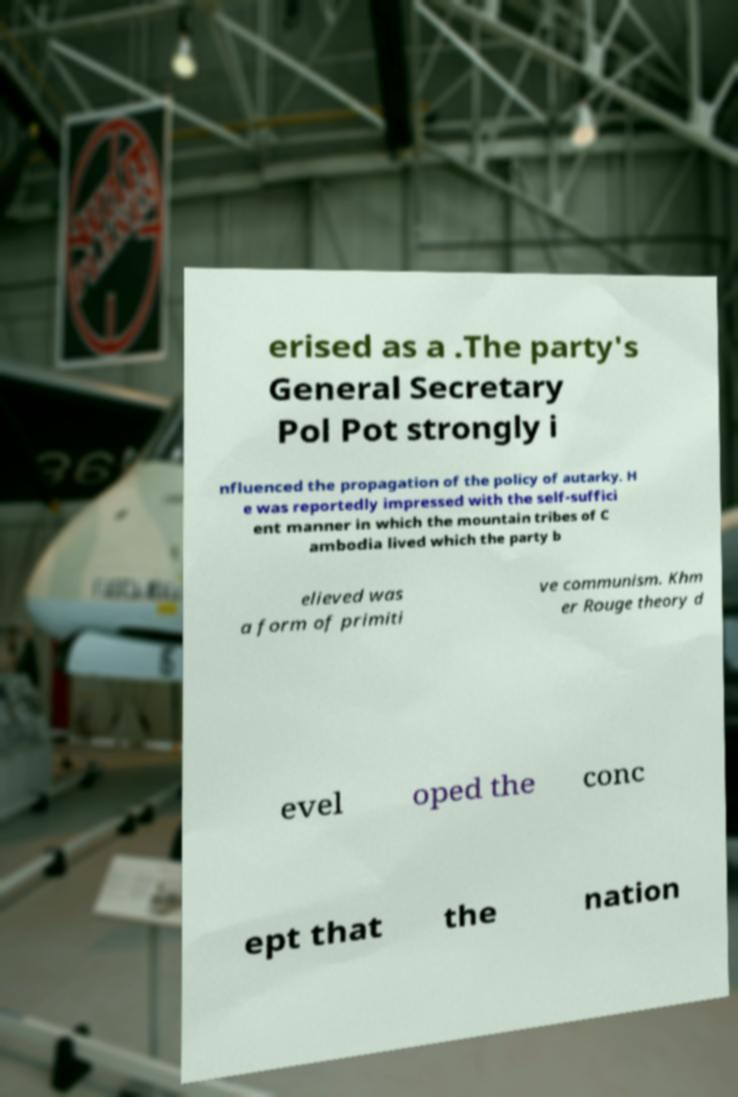Can you accurately transcribe the text from the provided image for me? erised as a .The party's General Secretary Pol Pot strongly i nfluenced the propagation of the policy of autarky. H e was reportedly impressed with the self-suffici ent manner in which the mountain tribes of C ambodia lived which the party b elieved was a form of primiti ve communism. Khm er Rouge theory d evel oped the conc ept that the nation 